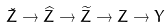<formula> <loc_0><loc_0><loc_500><loc_500>\check { Z } \to \widehat { Z } \to \widetilde { Z } \to Z \to Y</formula> 